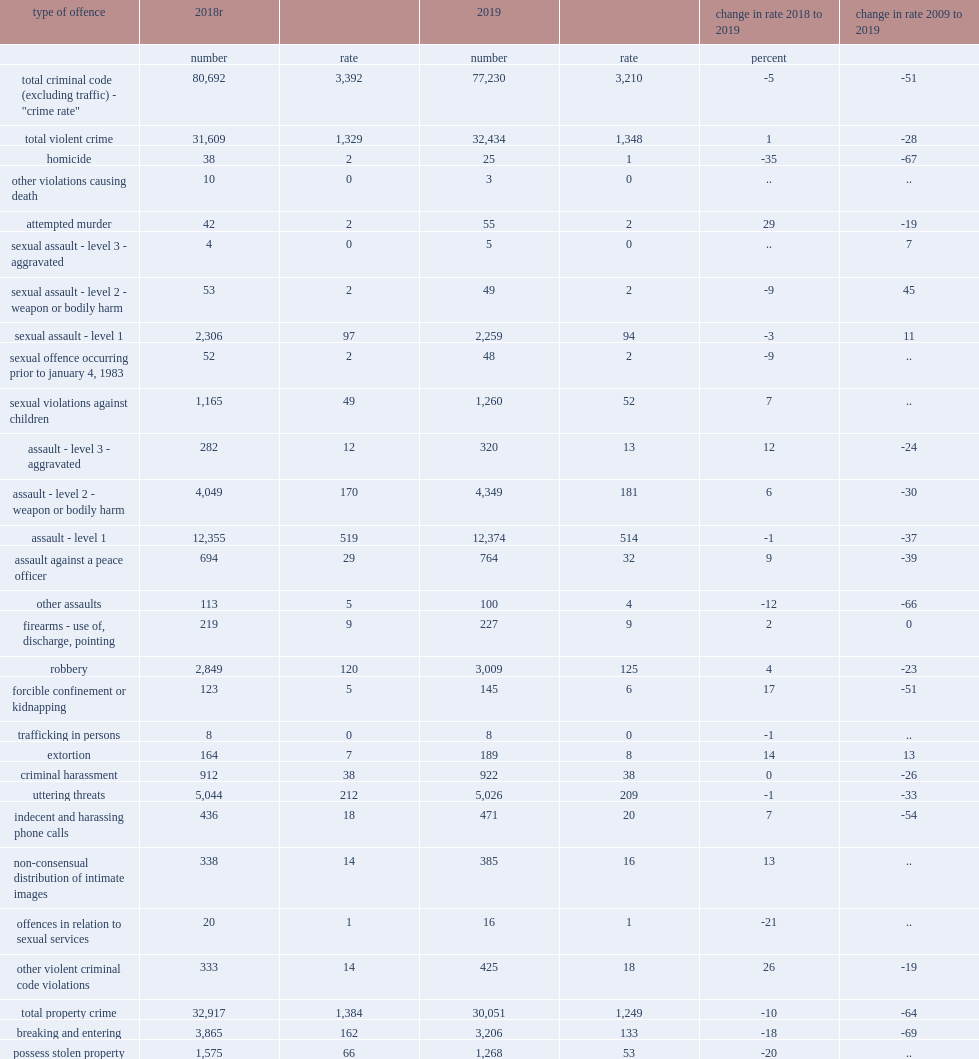What was the decline in the ycsi in 2019 which was primarily the result of decreases in the rate of youth accused of breaking and entering? -18.0. What was the decline in the ycsi in 2019 which was primarily the result of decreases in the rate of youth accused of homicide? -35.0. What was the decline in the ycsi in 2019 which was primarily the result of decreases in the rate of youth accused of possession of stolen property? -20.0. Similar to previous years, what was the rate of the most common criminal offences committed by youth in 2019 in level 1 assault? 514.0. Similar to previous years, what was the rate of the most common criminal offences committed by youth in 2019 in shoplifting of $5,000 or under? 423.0. Similar to previous years, what was the rate of the most common criminal offences committed by youth in 2019 in mischief? 346.0. 